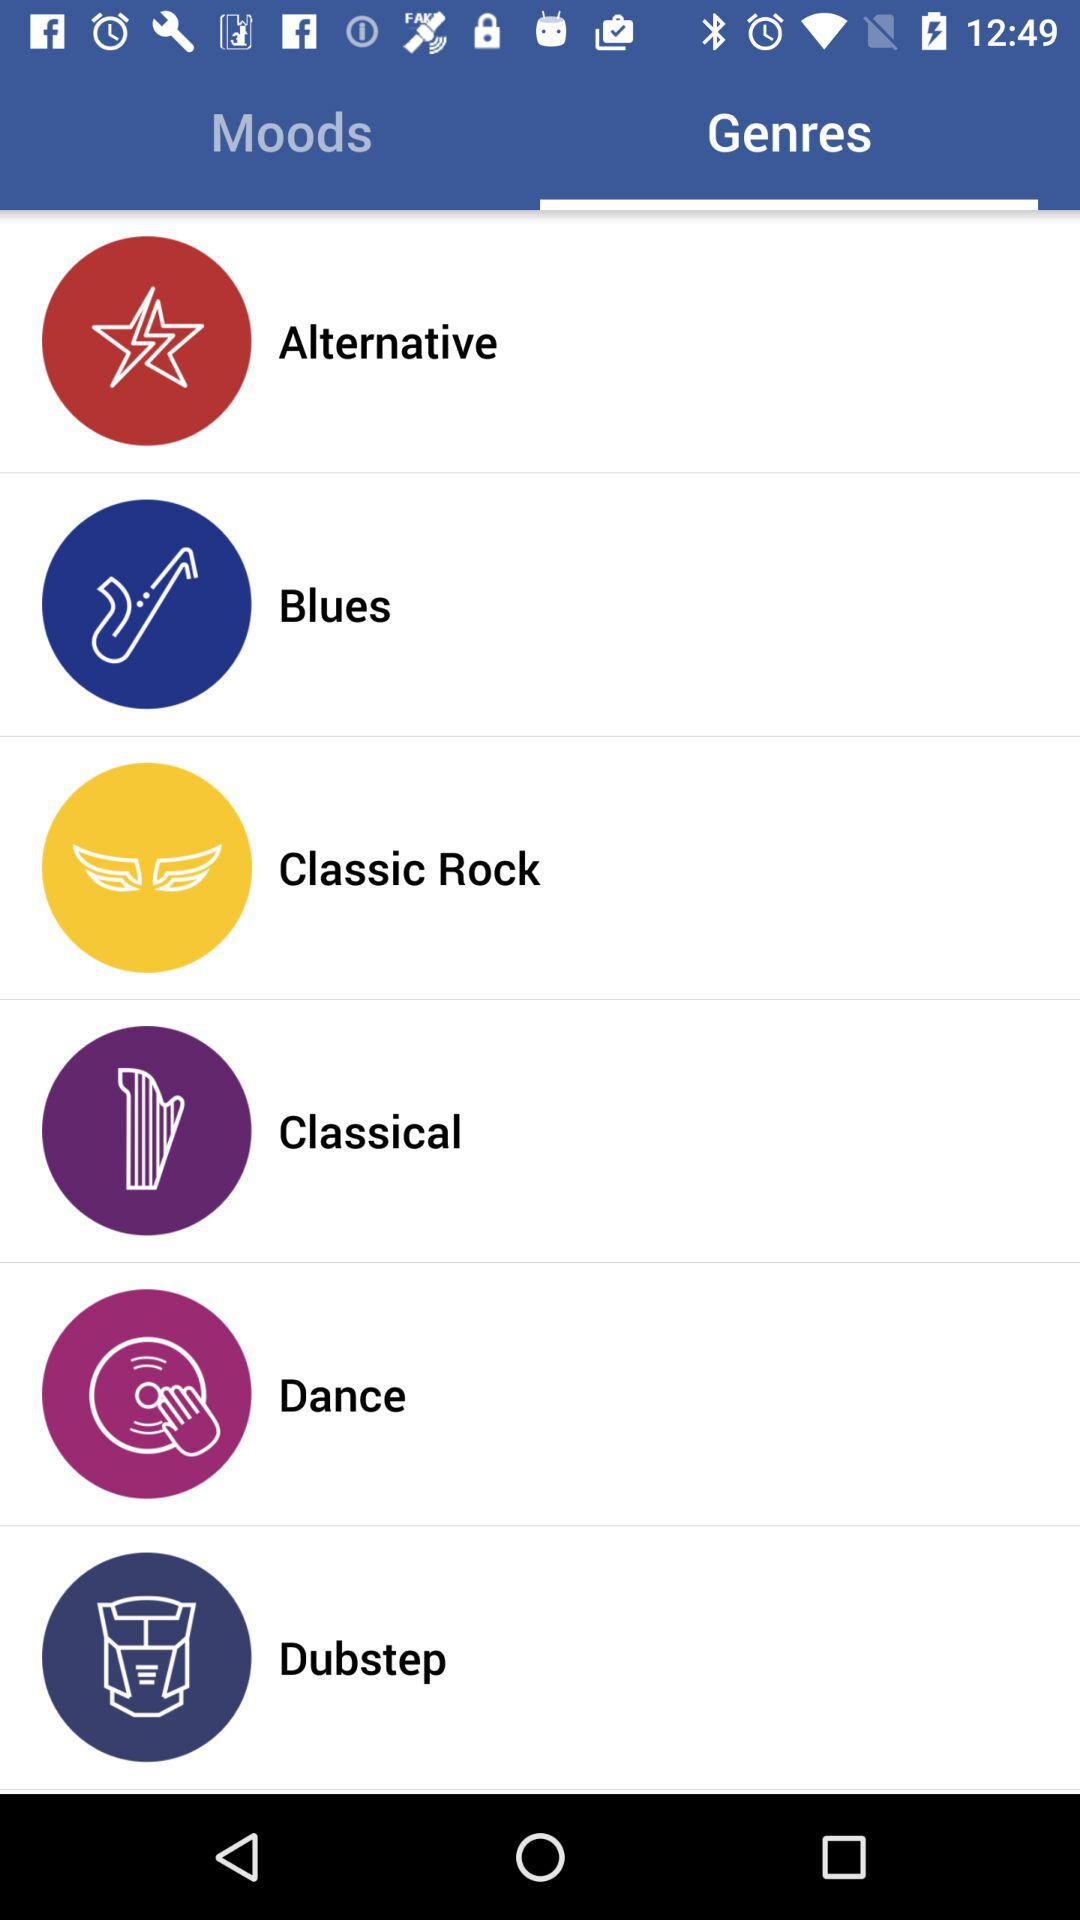What are the mentioned genres? The mentioned genres are "Alternative", "Blues", "Classic Rock", "Classical", "Dance" and "Dubstep". 